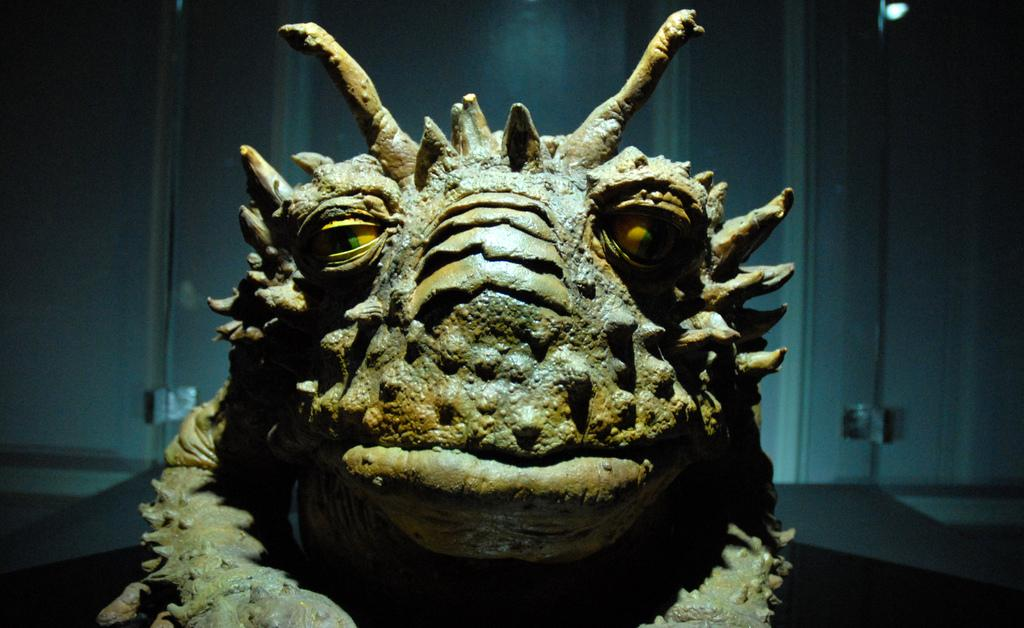What type of artwork is featured in the image? There is a sculpture of an animal in the image. What color is the background of the image? The background color is blue. Can you describe the lighting in the image? There is a light visible at the top of the image. What type of mask is the animal wearing in the image? There is no mask present in the image; it features a sculpture of an animal without any additional accessories. 